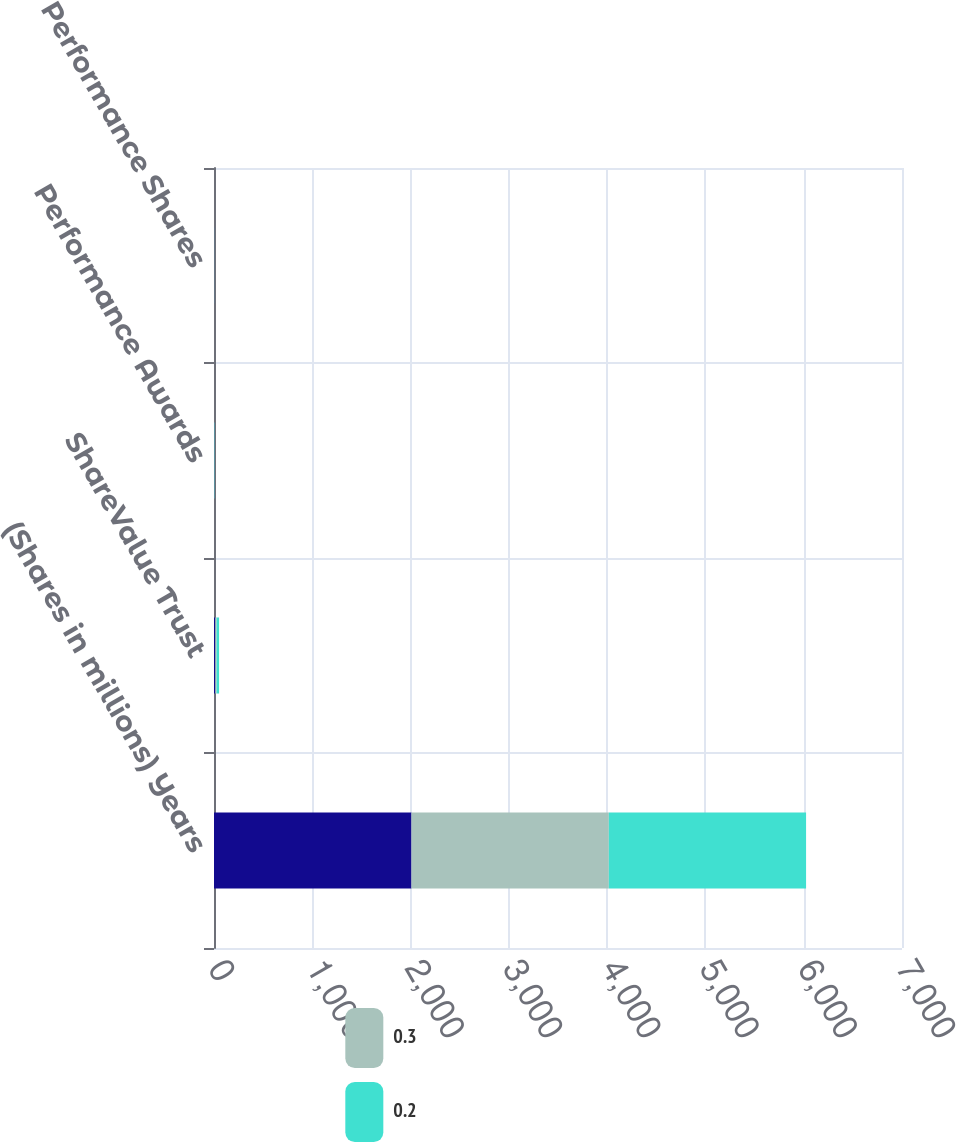<chart> <loc_0><loc_0><loc_500><loc_500><stacked_bar_chart><ecel><fcel>(Shares in millions) Years<fcel>ShareValue Trust<fcel>Performance Awards<fcel>Performance Shares<nl><fcel>nan<fcel>2009<fcel>13.2<fcel>2<fcel>0.8<nl><fcel>0.3<fcel>2008<fcel>12.7<fcel>2<fcel>0.7<nl><fcel>0.2<fcel>2007<fcel>25.8<fcel>3<fcel>0.7<nl></chart> 